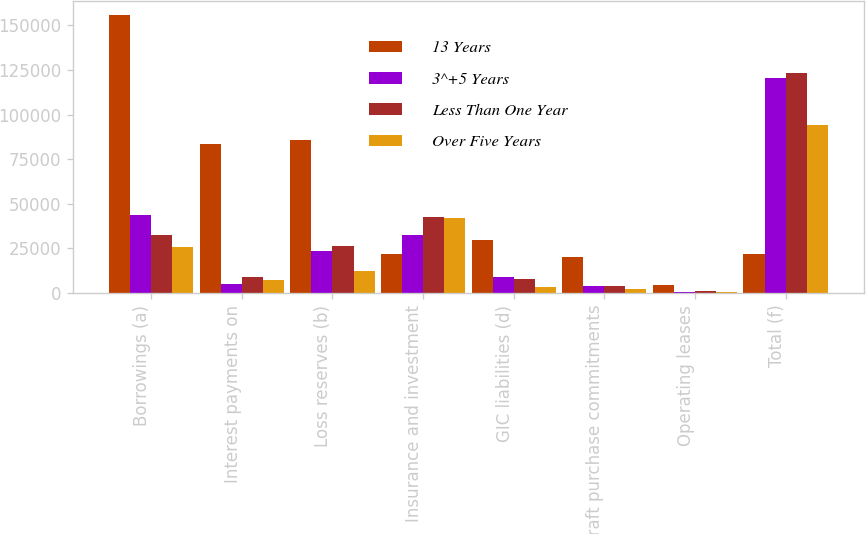Convert chart to OTSL. <chart><loc_0><loc_0><loc_500><loc_500><stacked_bar_chart><ecel><fcel>Borrowings (a)<fcel>Interest payments on<fcel>Loss reserves (b)<fcel>Insurance and investment<fcel>GIC liabilities (d)<fcel>Aircraft purchase commitments<fcel>Operating leases<fcel>Total (f)<nl><fcel>13 Years<fcel>156014<fcel>83551<fcel>85500<fcel>21808.5<fcel>29797<fcel>20104<fcel>4426<fcel>21808.5<nl><fcel>3^+5 Years<fcel>43891<fcel>5326<fcel>23513<fcel>32359<fcel>9266<fcel>4174<fcel>747<fcel>120332<nl><fcel>Less Than One Year<fcel>32261<fcel>8899<fcel>26078<fcel>42768<fcel>8052<fcel>3852<fcel>1041<fcel>122986<nl><fcel>Over Five Years<fcel>26032<fcel>7073<fcel>12397<fcel>42282<fcel>3458<fcel>2095<fcel>693<fcel>94030<nl></chart> 